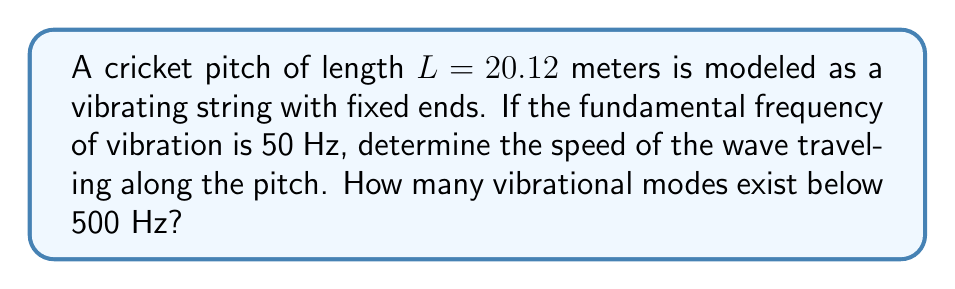Teach me how to tackle this problem. Let's approach this step-by-step:

1) For a string with fixed ends, the fundamental frequency $f_1$ is given by:

   $$f_1 = \frac{v}{2L}$$

   where $v$ is the wave speed and $L$ is the length of the string.

2) We're given $f_1 = 50$ Hz and $L = 20.12$ m. Let's solve for $v$:

   $$v = 2Lf_1 = 2 \cdot 20.12 \cdot 50 = 2012 \text{ m/s}$$

3) Now, for the second part of the question, we need to find how many modes exist below 500 Hz.

4) The frequency of the nth mode is given by:

   $$f_n = n \cdot f_1$$

5) We need to find the largest $n$ such that $f_n < 500$ Hz:

   $$n \cdot 50 < 500$$
   $$n < 10$$

6) Since $n$ must be an integer, the largest value it can take is 9.

Therefore, there are 9 vibrational modes below 500 Hz (modes 1 through 9).
Answer: Wave speed: 2012 m/s; Number of modes below 500 Hz: 9 